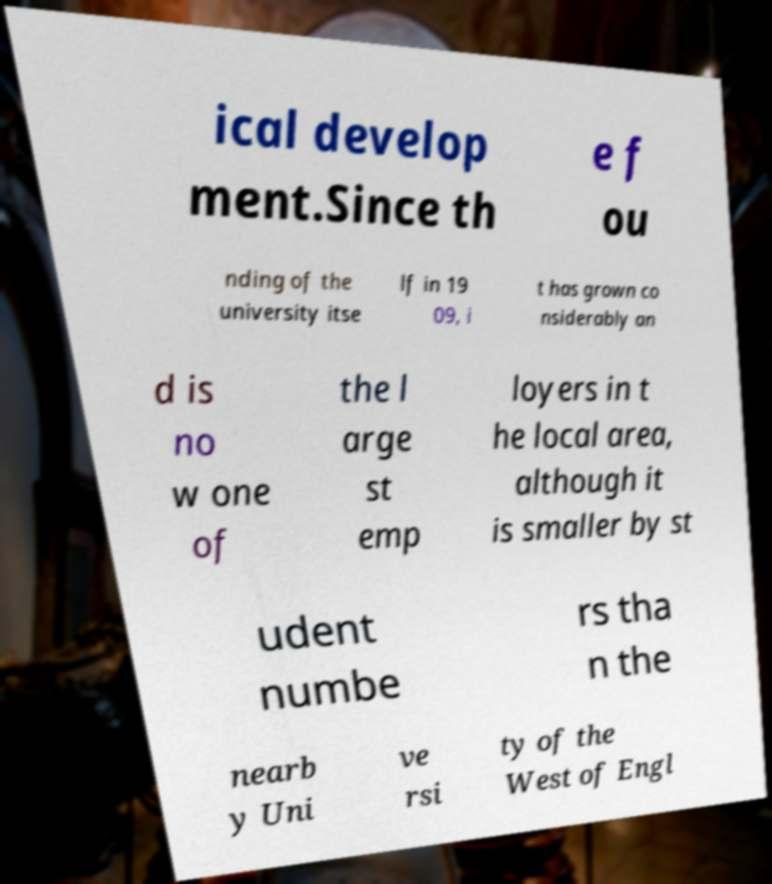I need the written content from this picture converted into text. Can you do that? ical develop ment.Since th e f ou nding of the university itse lf in 19 09, i t has grown co nsiderably an d is no w one of the l arge st emp loyers in t he local area, although it is smaller by st udent numbe rs tha n the nearb y Uni ve rsi ty of the West of Engl 